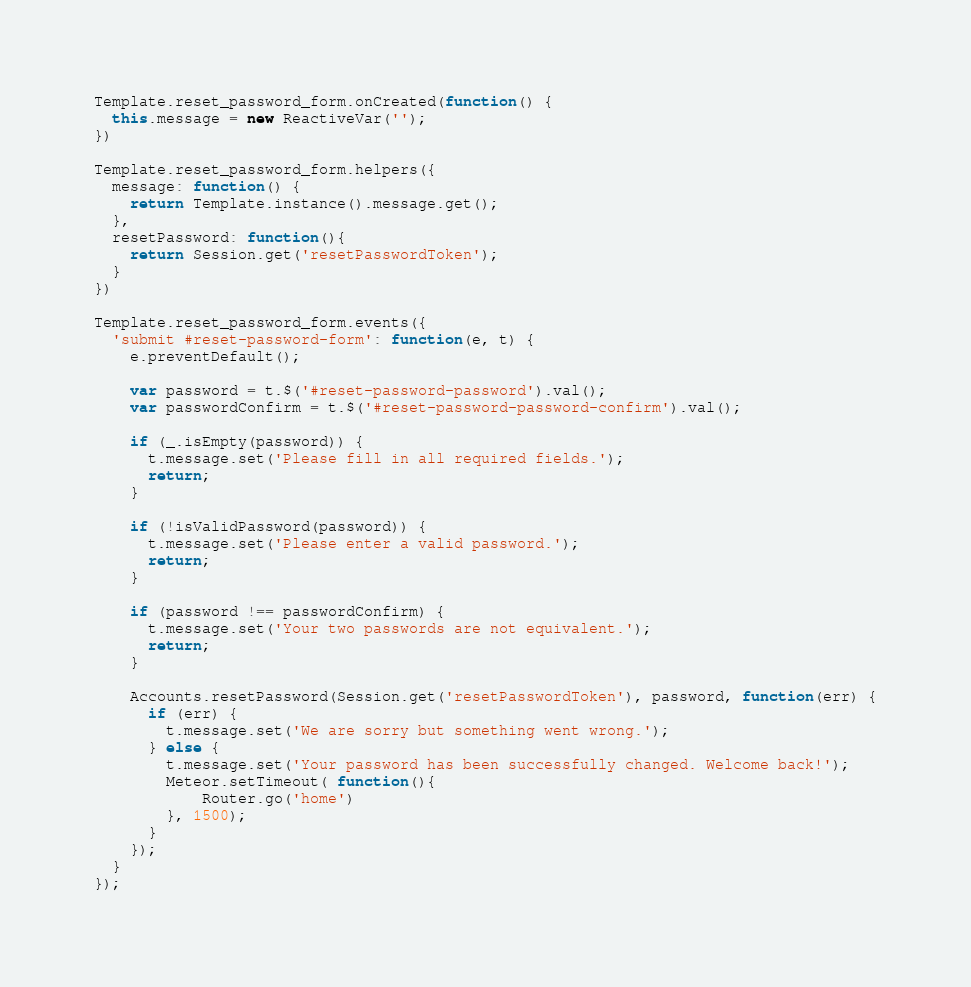<code> <loc_0><loc_0><loc_500><loc_500><_JavaScript_>Template.reset_password_form.onCreated(function() {
  this.message = new ReactiveVar('');
})

Template.reset_password_form.helpers({
  message: function() {
    return Template.instance().message.get();
  },
  resetPassword: function(){
    return Session.get('resetPasswordToken');
  }
})

Template.reset_password_form.events({
  'submit #reset-password-form': function(e, t) {
    e.preventDefault();
    
    var password = t.$('#reset-password-password').val();
    var passwordConfirm = t.$('#reset-password-password-confirm').val();

    if (_.isEmpty(password)) {
      t.message.set('Please fill in all required fields.');
      return;
    }

    if (!isValidPassword(password)) {
      t.message.set('Please enter a valid password.');
      return;
    }

    if (password !== passwordConfirm) {
      t.message.set('Your two passwords are not equivalent.');
      return;
    }
 
    Accounts.resetPassword(Session.get('resetPasswordToken'), password, function(err) {
      if (err) {
        t.message.set('We are sorry but something went wrong.');
      } else {
        t.message.set('Your password has been successfully changed. Welcome back!');
        Meteor.setTimeout( function(){
            Router.go('home')
        }, 1500);
      }
    });
  }
});
</code> 